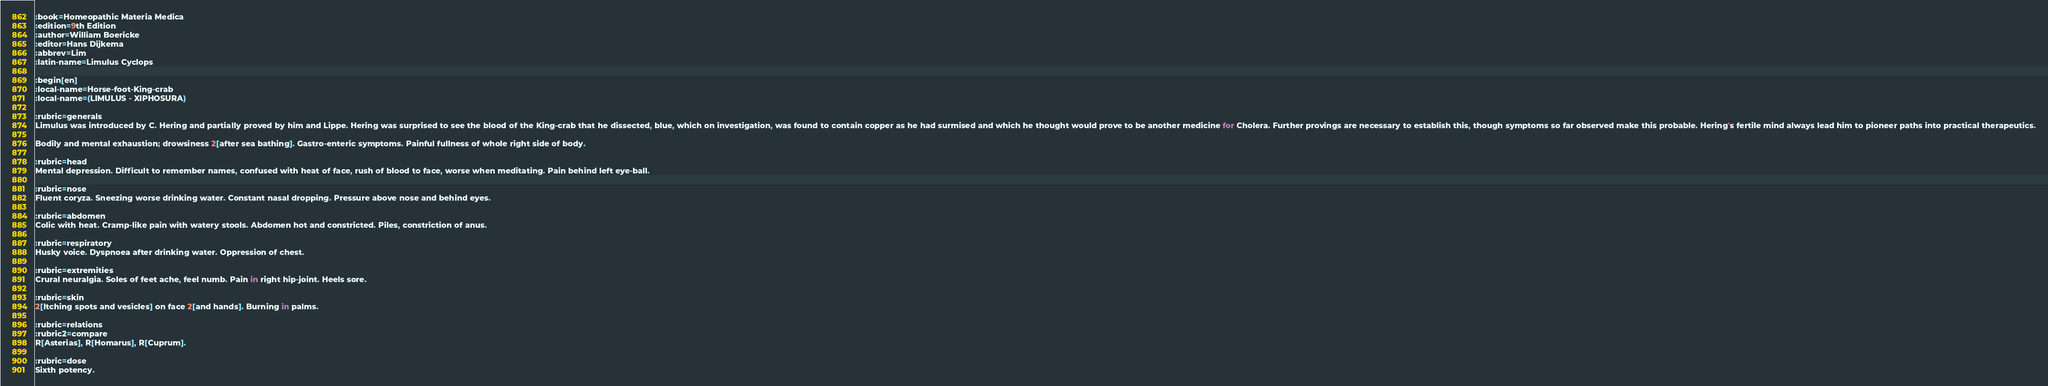Convert code to text. <code><loc_0><loc_0><loc_500><loc_500><_ObjectiveC_>:book=Homeopathic Materia Medica
:edition=9th Edition
:author=William Boericke
:editor=Hans Dijkema
:abbrev=Lim
:latin-name=Limulus Cyclops

:begin[en]
:local-name=Horse-foot-King-crab
:local-name=(LIMULUS - XIPHOSURA)

:rubric=generals
Limulus was introduced by C. Hering and partially proved by him and Lippe. Hering was surprised to see the blood of the King-crab that he dissected, blue, which on investigation, was found to contain copper as he had surmised and which he thought would prove to be another medicine for Cholera. Further provings are necessary to establish this, though symptoms so far observed make this probable. Hering's fertile mind always lead him to pioneer paths into practical therapeutics.

Bodily and mental exhaustion; drowsiness 2[after sea bathing]. Gastro-enteric symptoms. Painful fullness of whole right side of body.

:rubric=head
Mental depression. Difficult to remember names, confused with heat of face, rush of blood to face, worse when meditating. Pain behind left eye-ball.

:rubric=nose
Fluent coryza. Sneezing worse drinking water. Constant nasal dropping. Pressure above nose and behind eyes.

:rubric=abdomen
Colic with heat. Cramp-like pain with watery stools. Abdomen hot and constricted. Piles, constriction of anus.

:rubric=respiratory
Husky voice. Dyspnoea after drinking water. Oppression of chest.

:rubric=extremities
Crural neuralgia. Soles of feet ache, feel numb. Pain in right hip-joint. Heels sore.

:rubric=skin
2[Itching spots and vesicles] on face 2[and hands]. Burning in palms.

:rubric=relations
:rubric2=compare
R[Asterias], R[Homarus], R[Cuprum].

:rubric=dose
Sixth potency.

</code> 